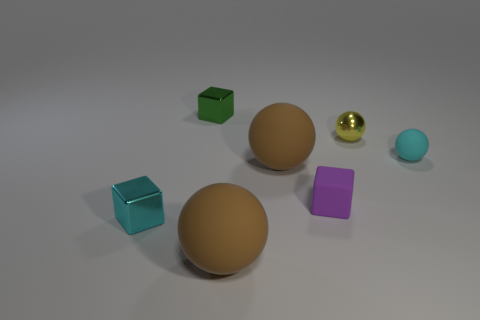What shape is the tiny cyan object that is to the right of the tiny green shiny object?
Provide a succinct answer. Sphere. Are the green block and the big thing behind the cyan shiny object made of the same material?
Ensure brevity in your answer.  No. Are there any things?
Your answer should be very brief. Yes. Is there a brown ball that is behind the tiny sphere to the right of the metal thing that is to the right of the purple thing?
Offer a very short reply. No. How many tiny things are cyan matte balls or cyan cubes?
Provide a short and direct response. 2. What color is the other metallic sphere that is the same size as the cyan sphere?
Offer a very short reply. Yellow. There is a small cyan metallic cube; how many small purple matte blocks are in front of it?
Make the answer very short. 0. Are there any small green cubes that have the same material as the yellow thing?
Your answer should be very brief. Yes. There is a tiny object that is the same color as the small matte ball; what shape is it?
Provide a short and direct response. Cube. The matte object that is in front of the small cyan metal thing is what color?
Offer a very short reply. Brown. 